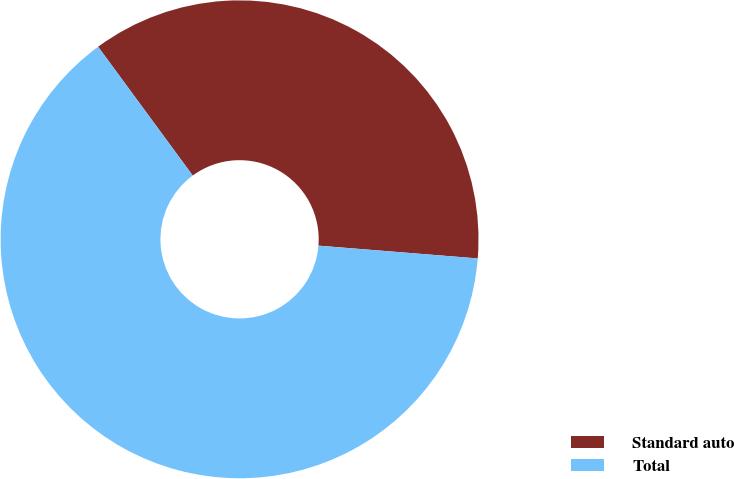Convert chart to OTSL. <chart><loc_0><loc_0><loc_500><loc_500><pie_chart><fcel>Standard auto<fcel>Total<nl><fcel>36.36%<fcel>63.64%<nl></chart> 